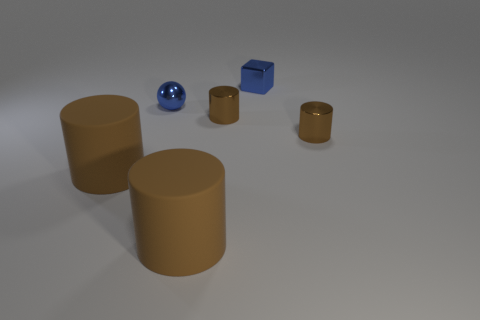What size is the thing that is the same color as the small ball?
Your answer should be compact. Small. What is the small object that is both left of the blue block and in front of the blue sphere made of?
Your answer should be compact. Metal. The tiny metallic cube right of the small brown shiny thing that is to the left of the tiny blue shiny block is what color?
Ensure brevity in your answer.  Blue. There is a small blue thing that is behind the tiny blue ball; what is its material?
Provide a short and direct response. Metal. Are there fewer balls than tiny metal objects?
Offer a very short reply. Yes. What is the shape of the shiny object that is both on the left side of the blue cube and in front of the small sphere?
Provide a succinct answer. Cylinder. Is the number of tiny blocks behind the small blue metal block the same as the number of big cylinders in front of the blue ball?
Your response must be concise. No. How many brown things are big matte blocks or rubber objects?
Your response must be concise. 2. What shape is the large brown rubber thing on the left side of the small blue ball?
Provide a short and direct response. Cylinder. Is there a cyan ball that has the same material as the blue ball?
Your response must be concise. No. 